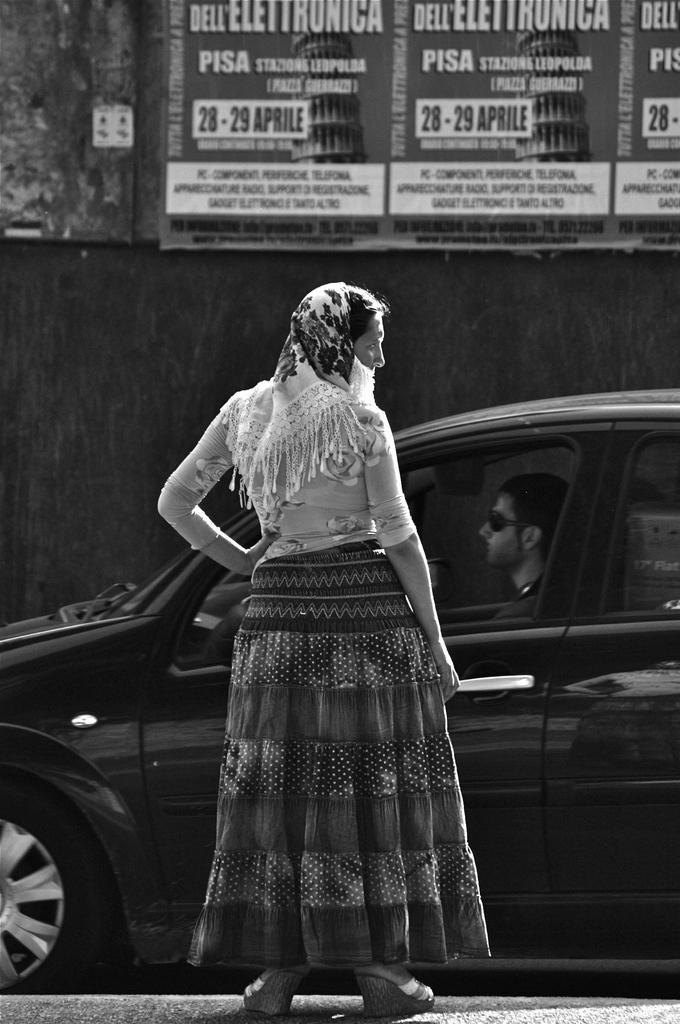In one or two sentences, can you explain what this image depicts? This is a picture of a lady who wore a white shirt and a gown in front of a lady there is a car and in the car there is guy who has spectacles. 